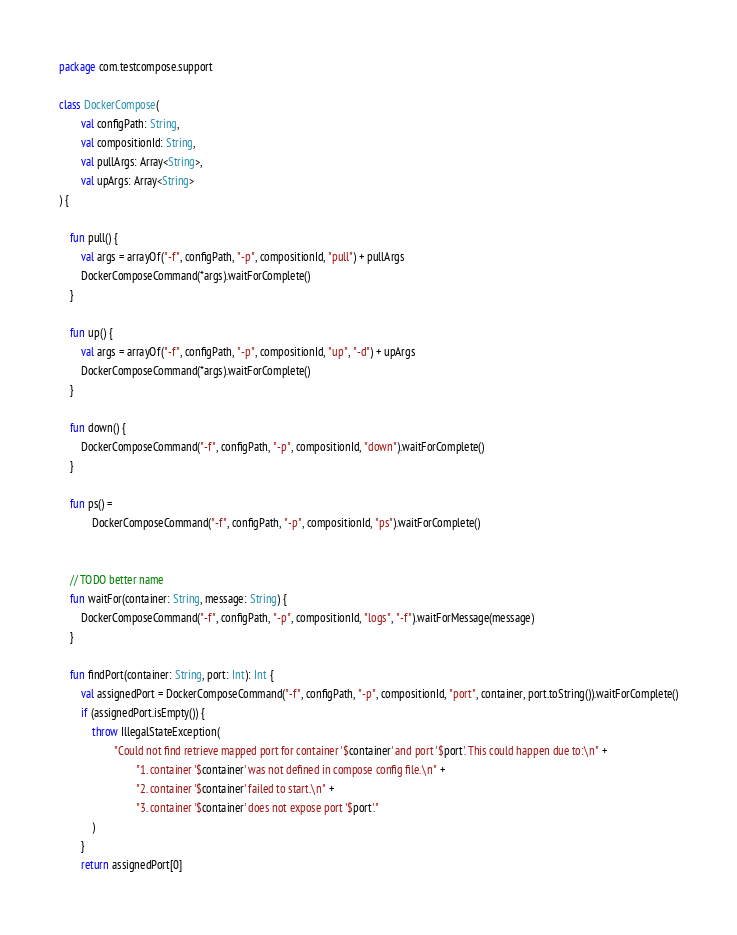Convert code to text. <code><loc_0><loc_0><loc_500><loc_500><_Kotlin_>package com.testcompose.support

class DockerCompose(
        val configPath: String,
        val compositionId: String,
        val pullArgs: Array<String>,
        val upArgs: Array<String>
) {

    fun pull() {
        val args = arrayOf("-f", configPath, "-p", compositionId, "pull") + pullArgs
        DockerComposeCommand(*args).waitForComplete()
    }

    fun up() {
        val args = arrayOf("-f", configPath, "-p", compositionId, "up", "-d") + upArgs
        DockerComposeCommand(*args).waitForComplete()
    }

    fun down() {
        DockerComposeCommand("-f", configPath, "-p", compositionId, "down").waitForComplete()
    }

    fun ps() =
            DockerComposeCommand("-f", configPath, "-p", compositionId, "ps").waitForComplete()


    // TODO better name
    fun waitFor(container: String, message: String) {
        DockerComposeCommand("-f", configPath, "-p", compositionId, "logs", "-f").waitForMessage(message)
    }

    fun findPort(container: String, port: Int): Int {
        val assignedPort = DockerComposeCommand("-f", configPath, "-p", compositionId, "port", container, port.toString()).waitForComplete()
        if (assignedPort.isEmpty()) {
            throw IllegalStateException(
                    "Could not find retrieve mapped port for container '$container' and port '$port'. This could happen due to:\n" +
                            "1. container '$container' was not defined in compose config file.\n" +
                            "2. container '$container' failed to start.\n" +
                            "3. container '$container' does not expose port '$port'."
            )
        }
        return assignedPort[0]</code> 